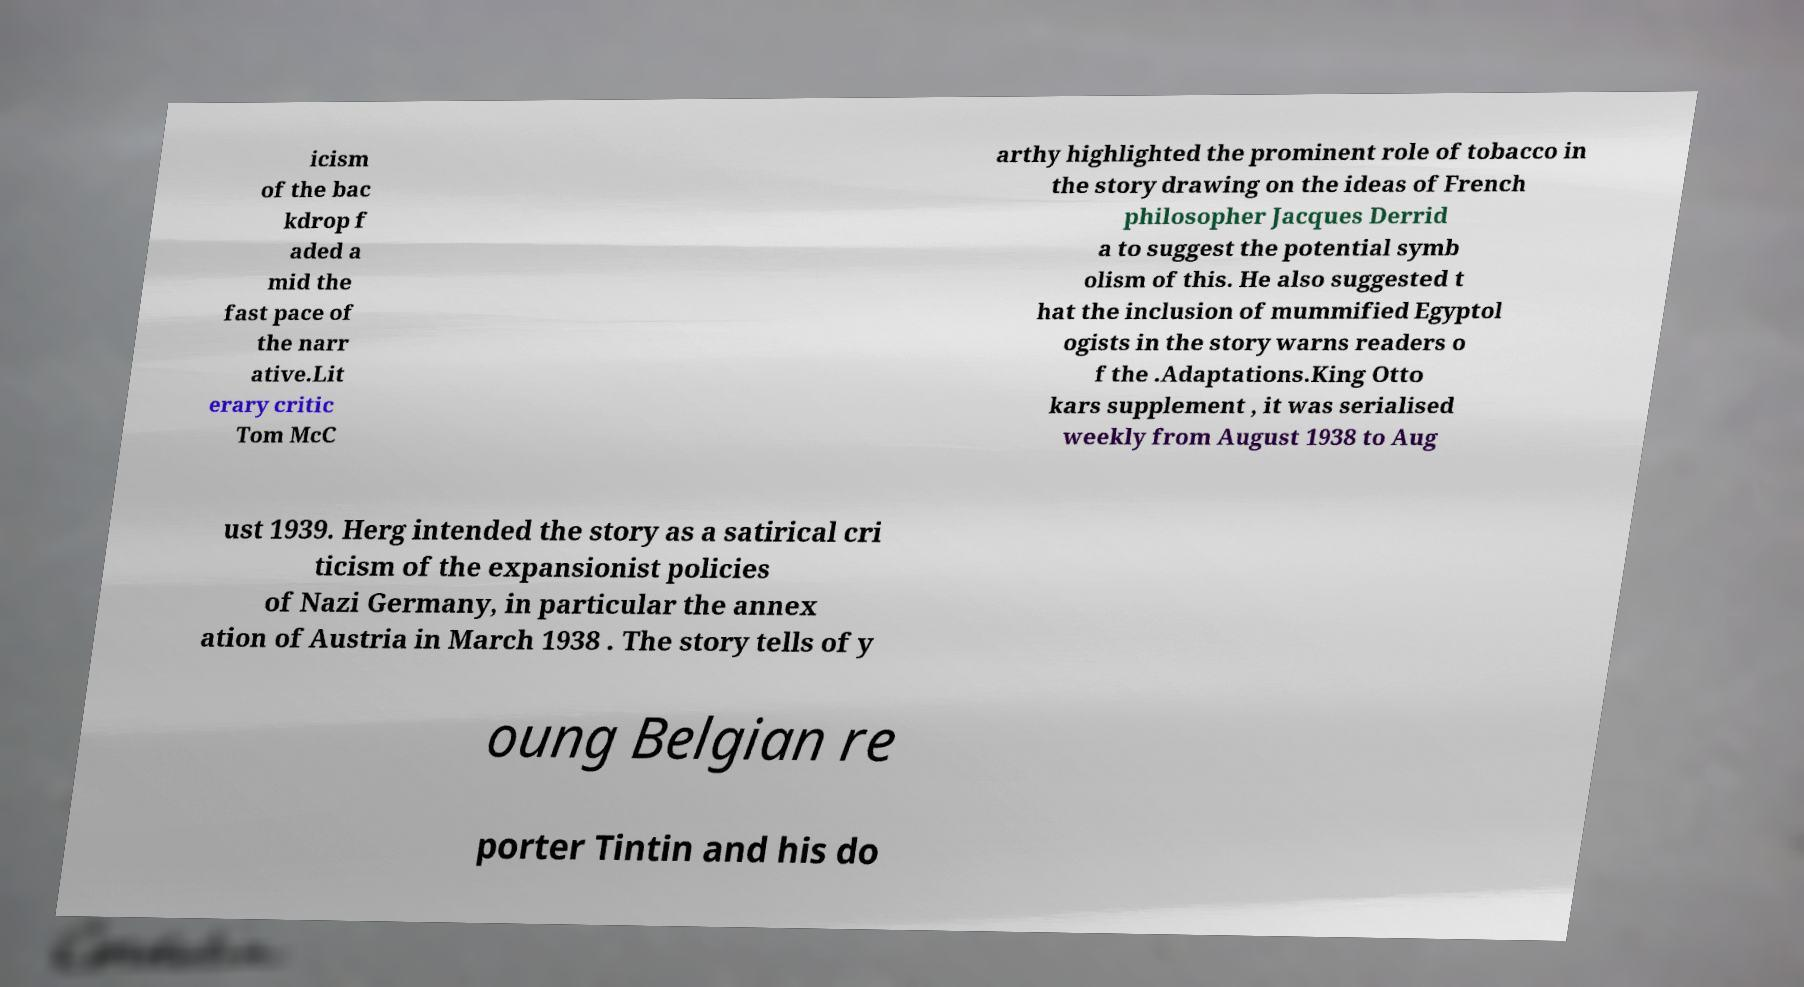What messages or text are displayed in this image? I need them in a readable, typed format. icism of the bac kdrop f aded a mid the fast pace of the narr ative.Lit erary critic Tom McC arthy highlighted the prominent role of tobacco in the story drawing on the ideas of French philosopher Jacques Derrid a to suggest the potential symb olism of this. He also suggested t hat the inclusion of mummified Egyptol ogists in the story warns readers o f the .Adaptations.King Otto kars supplement , it was serialised weekly from August 1938 to Aug ust 1939. Herg intended the story as a satirical cri ticism of the expansionist policies of Nazi Germany, in particular the annex ation of Austria in March 1938 . The story tells of y oung Belgian re porter Tintin and his do 